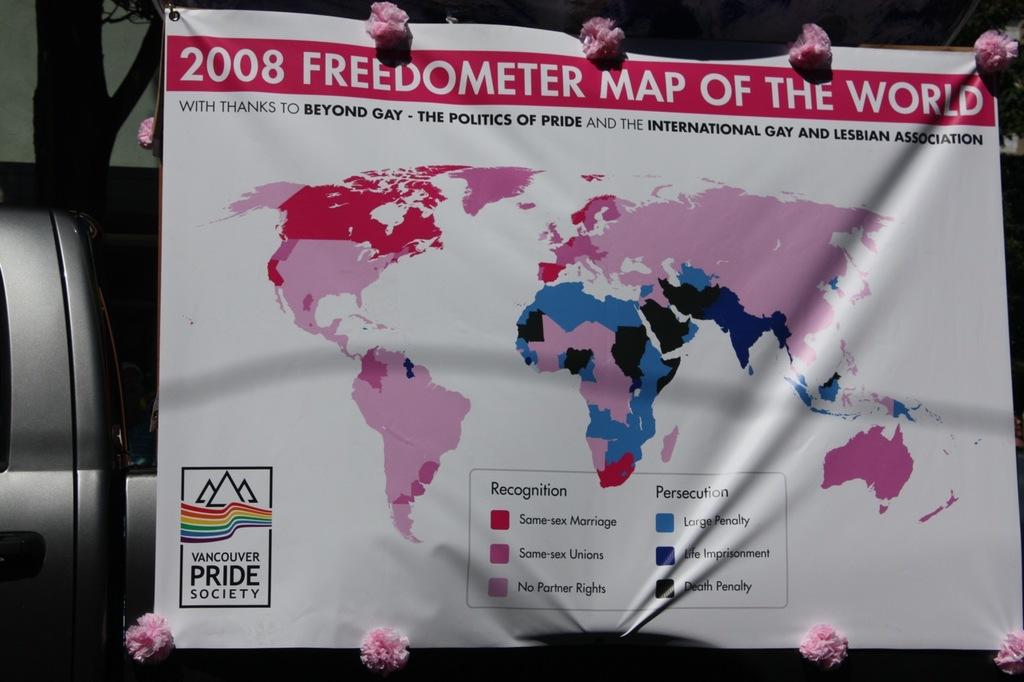What year is this map?
Offer a very short reply. 2008. What type of society is advertised near the bottom left of the poster?
Provide a succinct answer. Vancouver pride society. 